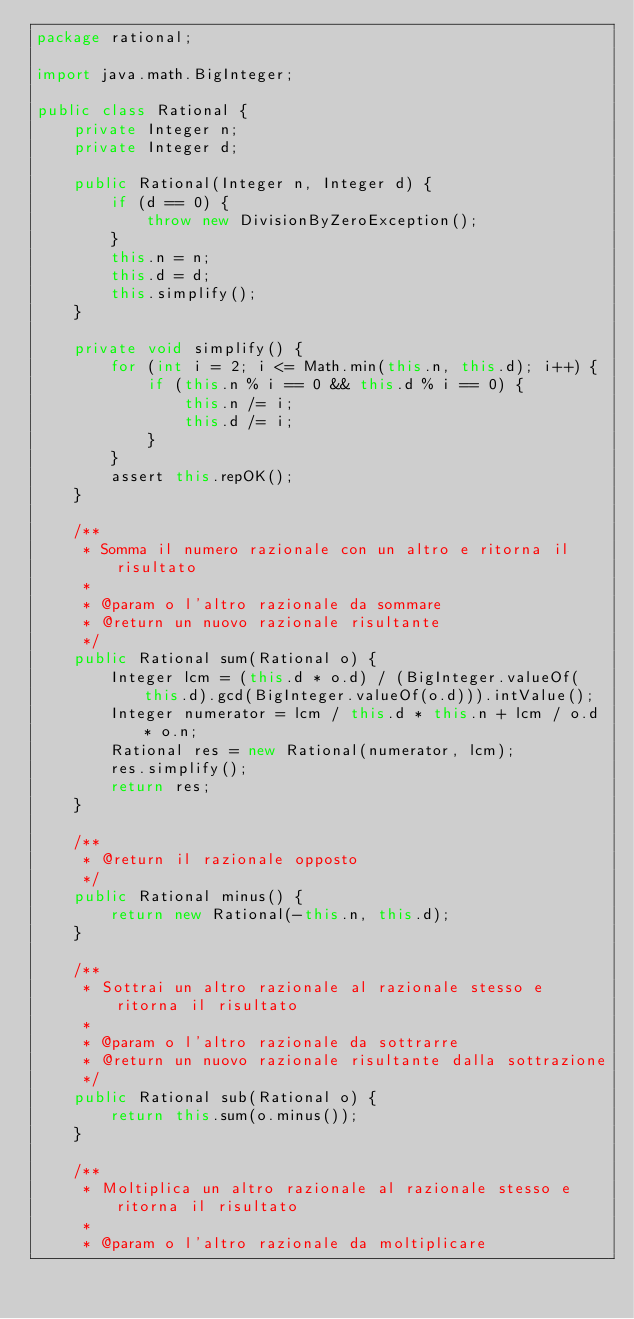Convert code to text. <code><loc_0><loc_0><loc_500><loc_500><_Java_>package rational;

import java.math.BigInteger;

public class Rational {
    private Integer n;
    private Integer d;

    public Rational(Integer n, Integer d) {
        if (d == 0) {
            throw new DivisionByZeroException();
        }
        this.n = n;
        this.d = d;
        this.simplify();
    }

    private void simplify() {
        for (int i = 2; i <= Math.min(this.n, this.d); i++) {
            if (this.n % i == 0 && this.d % i == 0) {
                this.n /= i;
                this.d /= i;
            }
        }
        assert this.repOK();
    }

    /**
     * Somma il numero razionale con un altro e ritorna il risultato
     *  
     * @param o l'altro razionale da sommare
     * @return un nuovo razionale risultante
     */
    public Rational sum(Rational o) {
        Integer lcm = (this.d * o.d) / (BigInteger.valueOf(this.d).gcd(BigInteger.valueOf(o.d))).intValue();
        Integer numerator = lcm / this.d * this.n + lcm / o.d * o.n;
        Rational res = new Rational(numerator, lcm);
        res.simplify();
        return res;
    }

    /**
     * @return il razionale opposto
     */
    public Rational minus() {
        return new Rational(-this.n, this.d);
    }

    /**
     * Sottrai un altro razionale al razionale stesso e ritorna il risultato
     * 
     * @param o l'altro razionale da sottrarre
     * @return un nuovo razionale risultante dalla sottrazione
     */
    public Rational sub(Rational o) {
        return this.sum(o.minus());
    }

    /**
     * Moltiplica un altro razionale al razionale stesso e ritorna il risultato
     * 
     * @param o l'altro razionale da moltiplicare</code> 